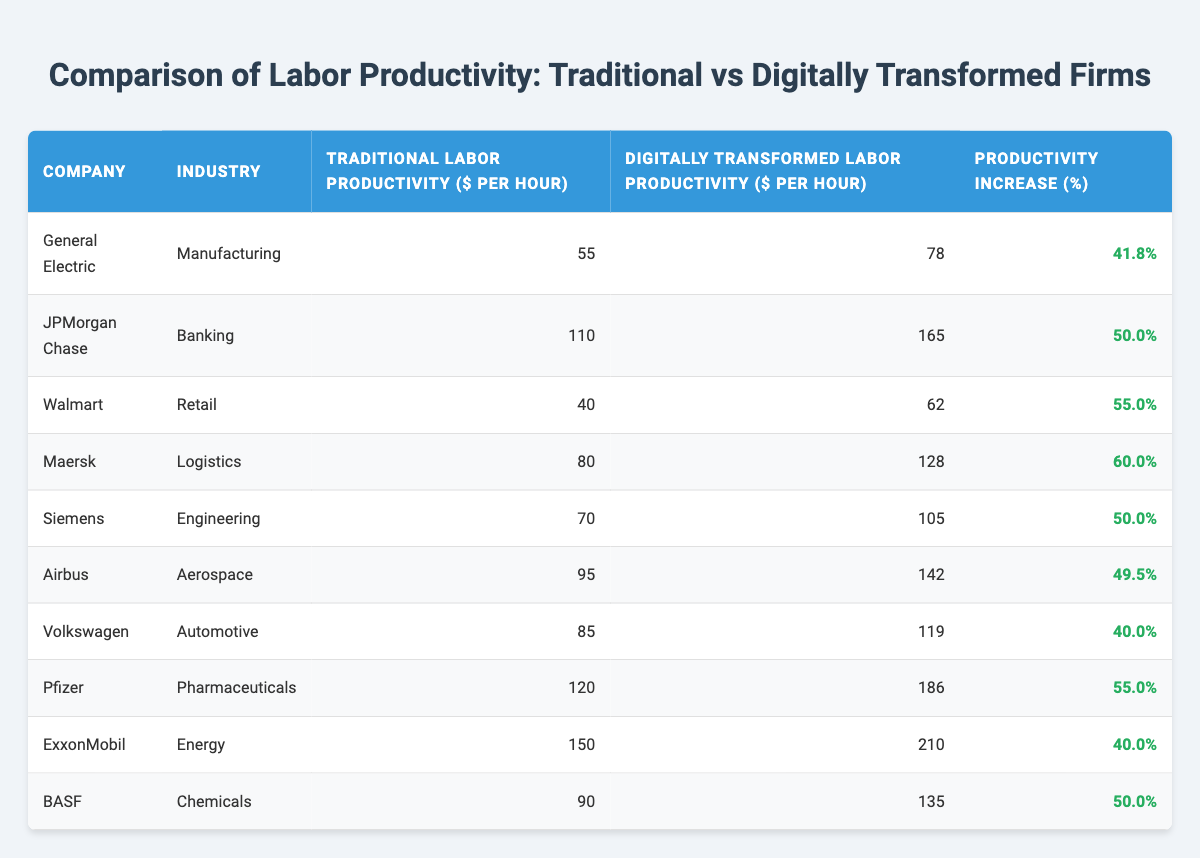What is the traditional labor productivity of Walmart? From the table, the traditional labor productivity for Walmart is given as 40 dollars per hour. This value is directly available in the "Traditional Labor Productivity" column next to Walmart in the corresponding row.
Answer: 40 Which company showed the highest productivity increase percentage? By comparing the "Productivity Increase (%)" column, Maersk has the highest value at 60.0 percent, which is found in the corresponding row. This indicates that among all the companies listed, Maersk achieved the largest percentage increase in labor productivity.
Answer: 60.0 What is the average traditional labor productivity for all companies listed? To find the average, we sum the traditional labor productivity values: 55 + 110 + 40 + 80 + 70 + 95 + 85 + 120 + 150 + 90 = 1,000. There are 10 companies in total, so the average is 1000/10 = 100.
Answer: 100 Did any company in the pharmaceutical industry increase its labor productivity by more than 50%? The only company listed in the pharmaceutical industry is Pfizer, which has a productivity increase of 55.0 percent. Since this value is greater than 50 percent, the answer is yes, confirming that Pfizer did exceed that increase.
Answer: Yes What is the difference in labor productivity between ExxonMobil's traditional and digitally transformed productivity? From the table, ExxonMobil's traditional labor productivity is 150 dollars per hour, and its digitally transformed productivity is 210 dollars per hour. The difference can be calculated as 210 - 150 = 60 dollars per hour, indicating how much more productive the firm became after digital transformation.
Answer: 60 What percentage increase did Volkswagen achieve in labor productivity? For Volkswagen, the productivity increase is listed as 40.0 percent in the table. This means that the company achieved an increase of 40.0 percent from its traditional labor productivity after undergoing digital transformation.
Answer: 40.0 Which industry has the company with the lowest traditional labor productivity? By examining the "Traditional Labor Productivity" column, it can be seen that Walmart has the lowest traditional productivity at 40 dollars per hour, which is the minimum among all the companies in their respective industries.
Answer: Retail Which two companies had a productivity increase of exactly 50%? Looking at the "Productivity Increase (%)" column, both Siemens and BASF show a productivity increase of 50.0 percent. We can identify them by checking the corresponding rows in the table and verifying their increase percentages.
Answer: Siemens and BASF Is it true that the average digitally transformed labor productivity across the listed companies is greater than 120 dollars per hour? We will calculate the average for the digitally transformed labor productivity: 78 + 165 + 62 + 128 + 105 + 142 + 119 + 186 + 210 + 135 = 1,860. Then, divide by the number of companies: 1860/10 = 186. Since 186 is greater than 120, the statement is true.
Answer: Yes 